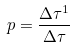<formula> <loc_0><loc_0><loc_500><loc_500>p = \frac { \Delta \tau ^ { 1 } } { \Delta \tau }</formula> 